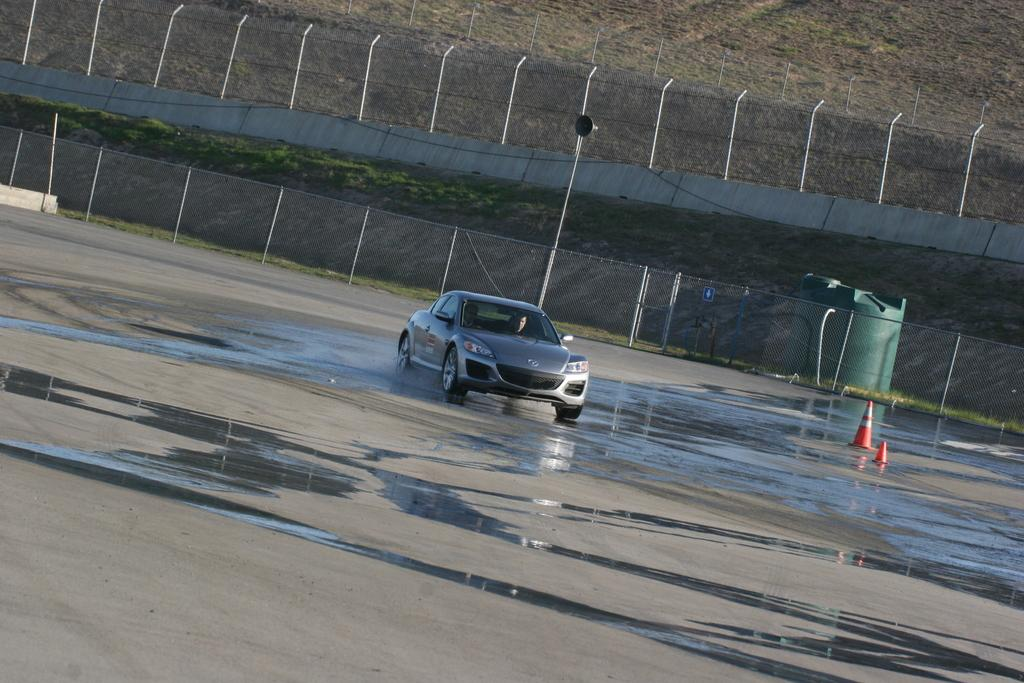What is the main subject of the image? There is a car in the image. What is the car doing in the image? The car is moving on the road. What can be seen in the background of the image? There is a net fence, metal poles, and grass visible in the background of the image. What type of legal advice is the car seeking in the image? There is no lawyer or legal advice present in the image; it features a car moving on the road. What type of drug can be seen in the image? There is no drug present in the image; it features a car moving on the road. 